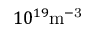Convert formula to latex. <formula><loc_0><loc_0><loc_500><loc_500>1 0 ^ { 1 9 } { m } ^ { - 3 }</formula> 